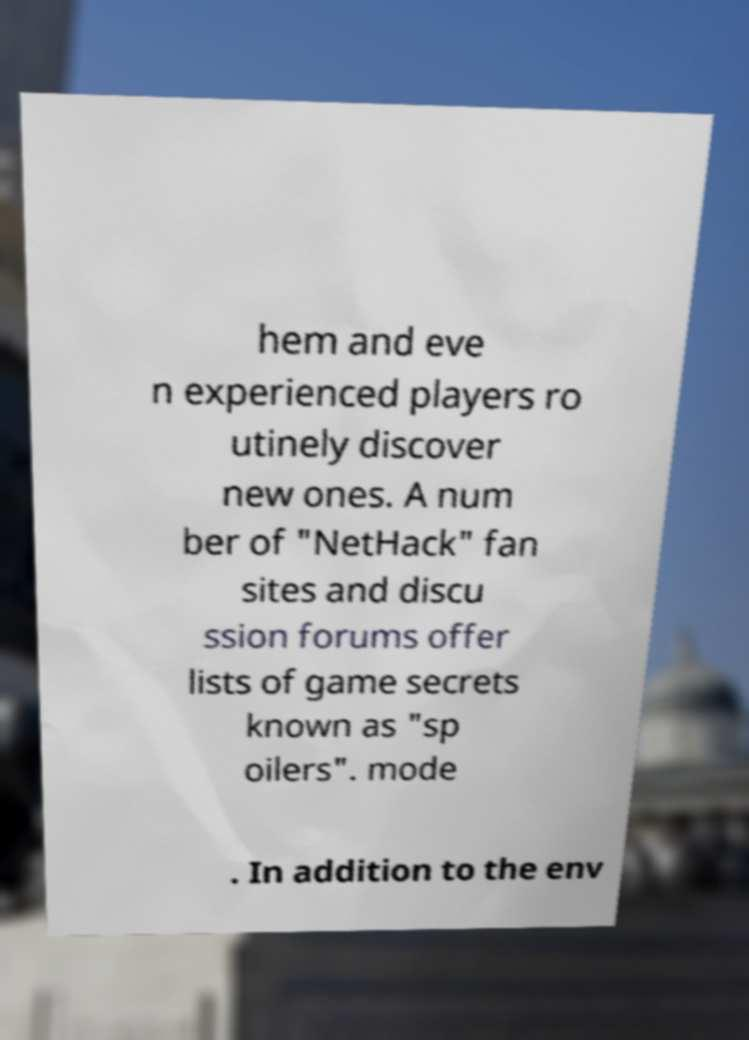What messages or text are displayed in this image? I need them in a readable, typed format. hem and eve n experienced players ro utinely discover new ones. A num ber of "NetHack" fan sites and discu ssion forums offer lists of game secrets known as "sp oilers". mode . In addition to the env 